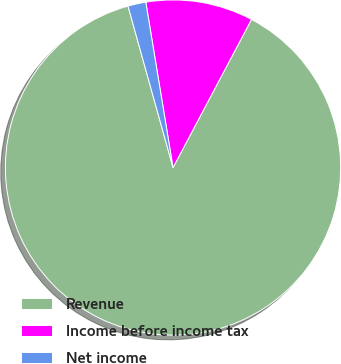Convert chart. <chart><loc_0><loc_0><loc_500><loc_500><pie_chart><fcel>Revenue<fcel>Income before income tax<fcel>Net income<nl><fcel>87.91%<fcel>10.35%<fcel>1.73%<nl></chart> 